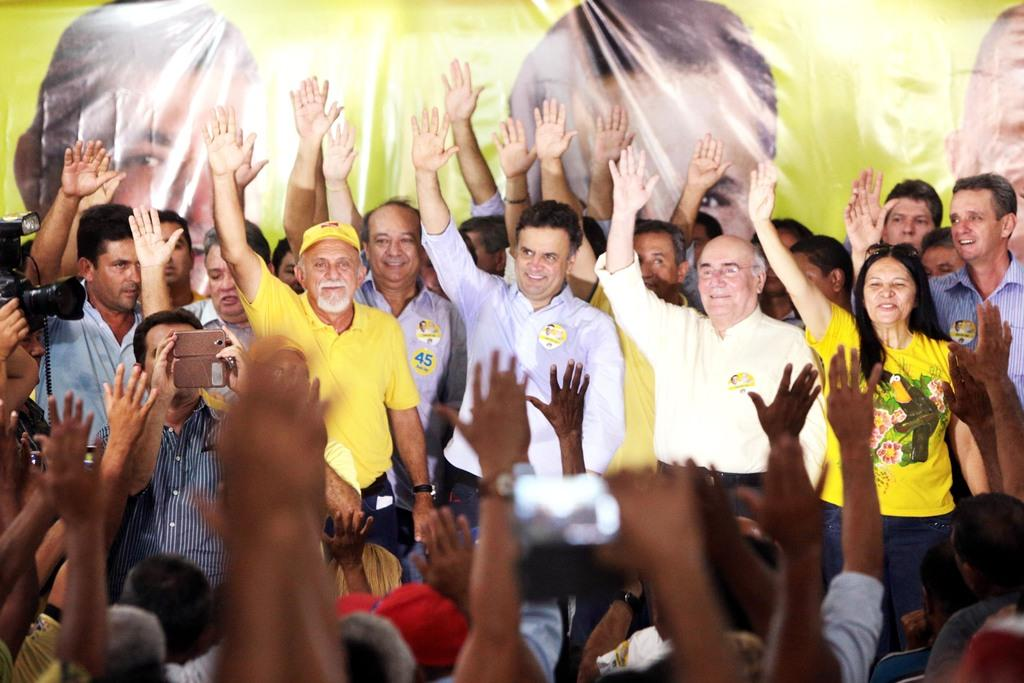What are the people in the image doing? The people in the image are standing and raising their hands. Can you describe the poster in the background of the image? Unfortunately, the provided facts do not give any information about the poster in the background. What might be the reason for the people raising their hands in the image? Without additional context, it is difficult to determine the reason for the people raising their hands in the image. What type of lettuce is being used as a control mechanism in the image? There is no lettuce present in the image, and therefore no such control mechanism can be observed. 